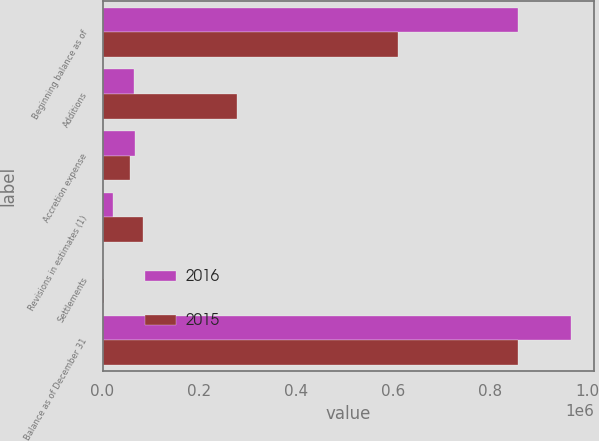<chart> <loc_0><loc_0><loc_500><loc_500><stacked_bar_chart><ecel><fcel>Beginning balance as of<fcel>Additions<fcel>Accretion expense<fcel>Revisions in estimates (1)<fcel>Settlements<fcel>Balance as of December 31<nl><fcel>2016<fcel>856936<fcel>64092<fcel>67010<fcel>21130<fcel>1401<fcel>965507<nl><fcel>2015<fcel>609035<fcel>277982<fcel>55592<fcel>83636<fcel>2037<fcel>856936<nl></chart> 